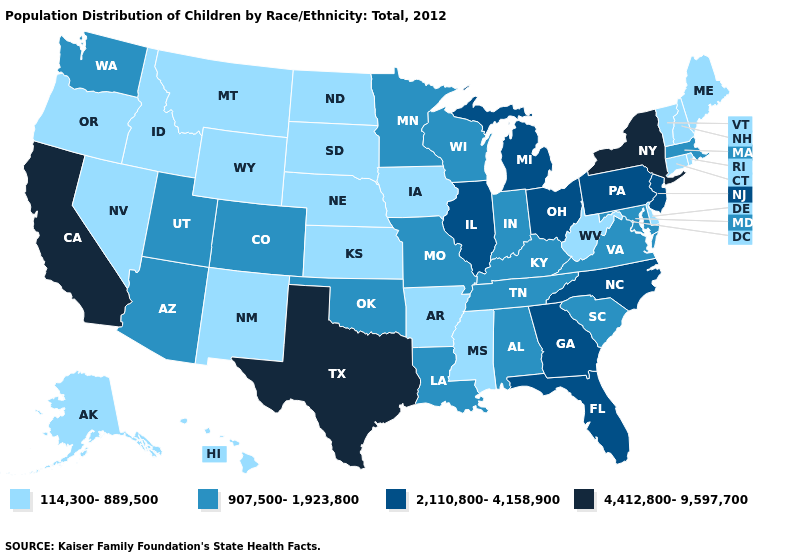Which states have the lowest value in the USA?
Keep it brief. Alaska, Arkansas, Connecticut, Delaware, Hawaii, Idaho, Iowa, Kansas, Maine, Mississippi, Montana, Nebraska, Nevada, New Hampshire, New Mexico, North Dakota, Oregon, Rhode Island, South Dakota, Vermont, West Virginia, Wyoming. What is the value of Maryland?
Be succinct. 907,500-1,923,800. Does New York have the same value as Alabama?
Concise answer only. No. How many symbols are there in the legend?
Concise answer only. 4. Name the states that have a value in the range 2,110,800-4,158,900?
Be succinct. Florida, Georgia, Illinois, Michigan, New Jersey, North Carolina, Ohio, Pennsylvania. Name the states that have a value in the range 4,412,800-9,597,700?
Write a very short answer. California, New York, Texas. Among the states that border Nebraska , does Iowa have the lowest value?
Give a very brief answer. Yes. What is the value of Alaska?
Be succinct. 114,300-889,500. What is the value of Connecticut?
Keep it brief. 114,300-889,500. What is the value of Minnesota?
Concise answer only. 907,500-1,923,800. Among the states that border Missouri , does Kentucky have the highest value?
Give a very brief answer. No. What is the value of West Virginia?
Write a very short answer. 114,300-889,500. Among the states that border Mississippi , does Tennessee have the highest value?
Concise answer only. Yes. Name the states that have a value in the range 4,412,800-9,597,700?
Give a very brief answer. California, New York, Texas. What is the highest value in the MidWest ?
Quick response, please. 2,110,800-4,158,900. 